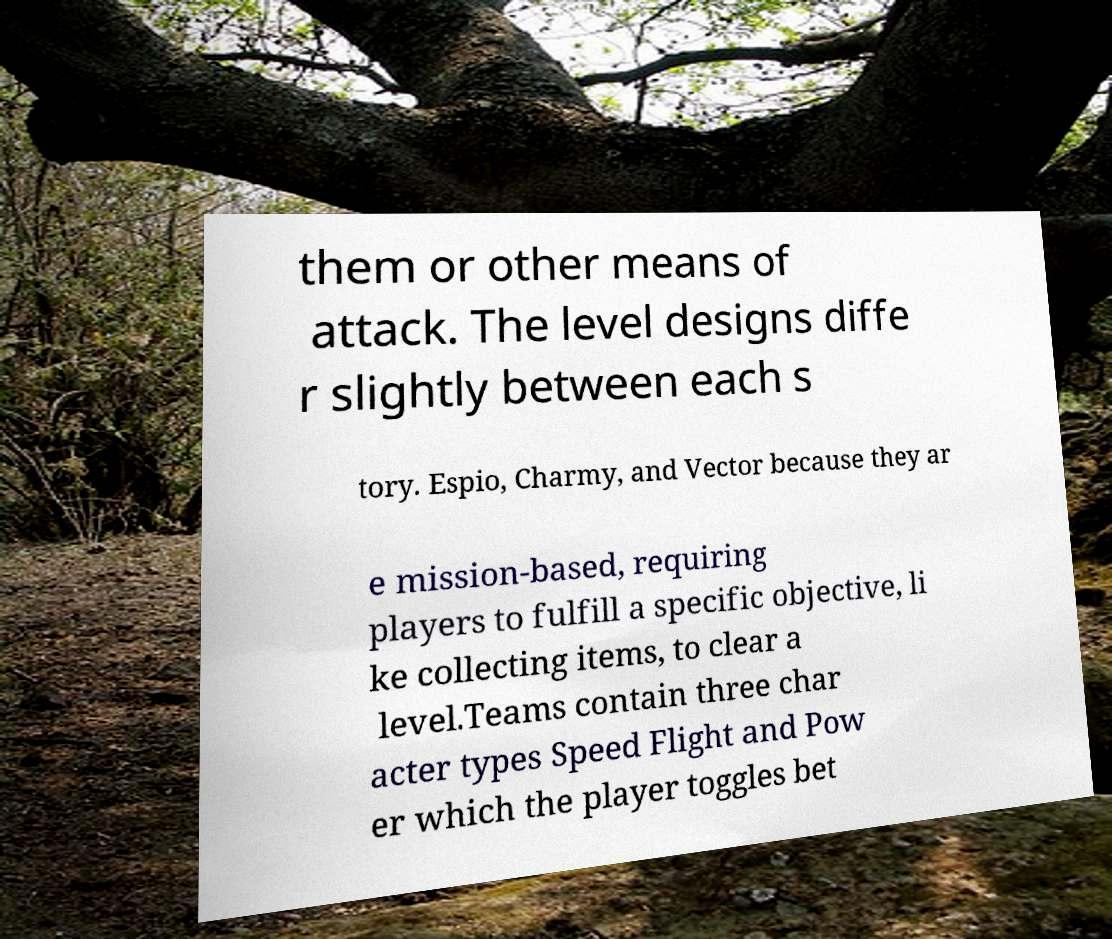Can you read and provide the text displayed in the image?This photo seems to have some interesting text. Can you extract and type it out for me? them or other means of attack. The level designs diffe r slightly between each s tory. Espio, Charmy, and Vector because they ar e mission-based, requiring players to fulfill a specific objective, li ke collecting items, to clear a level.Teams contain three char acter types Speed Flight and Pow er which the player toggles bet 